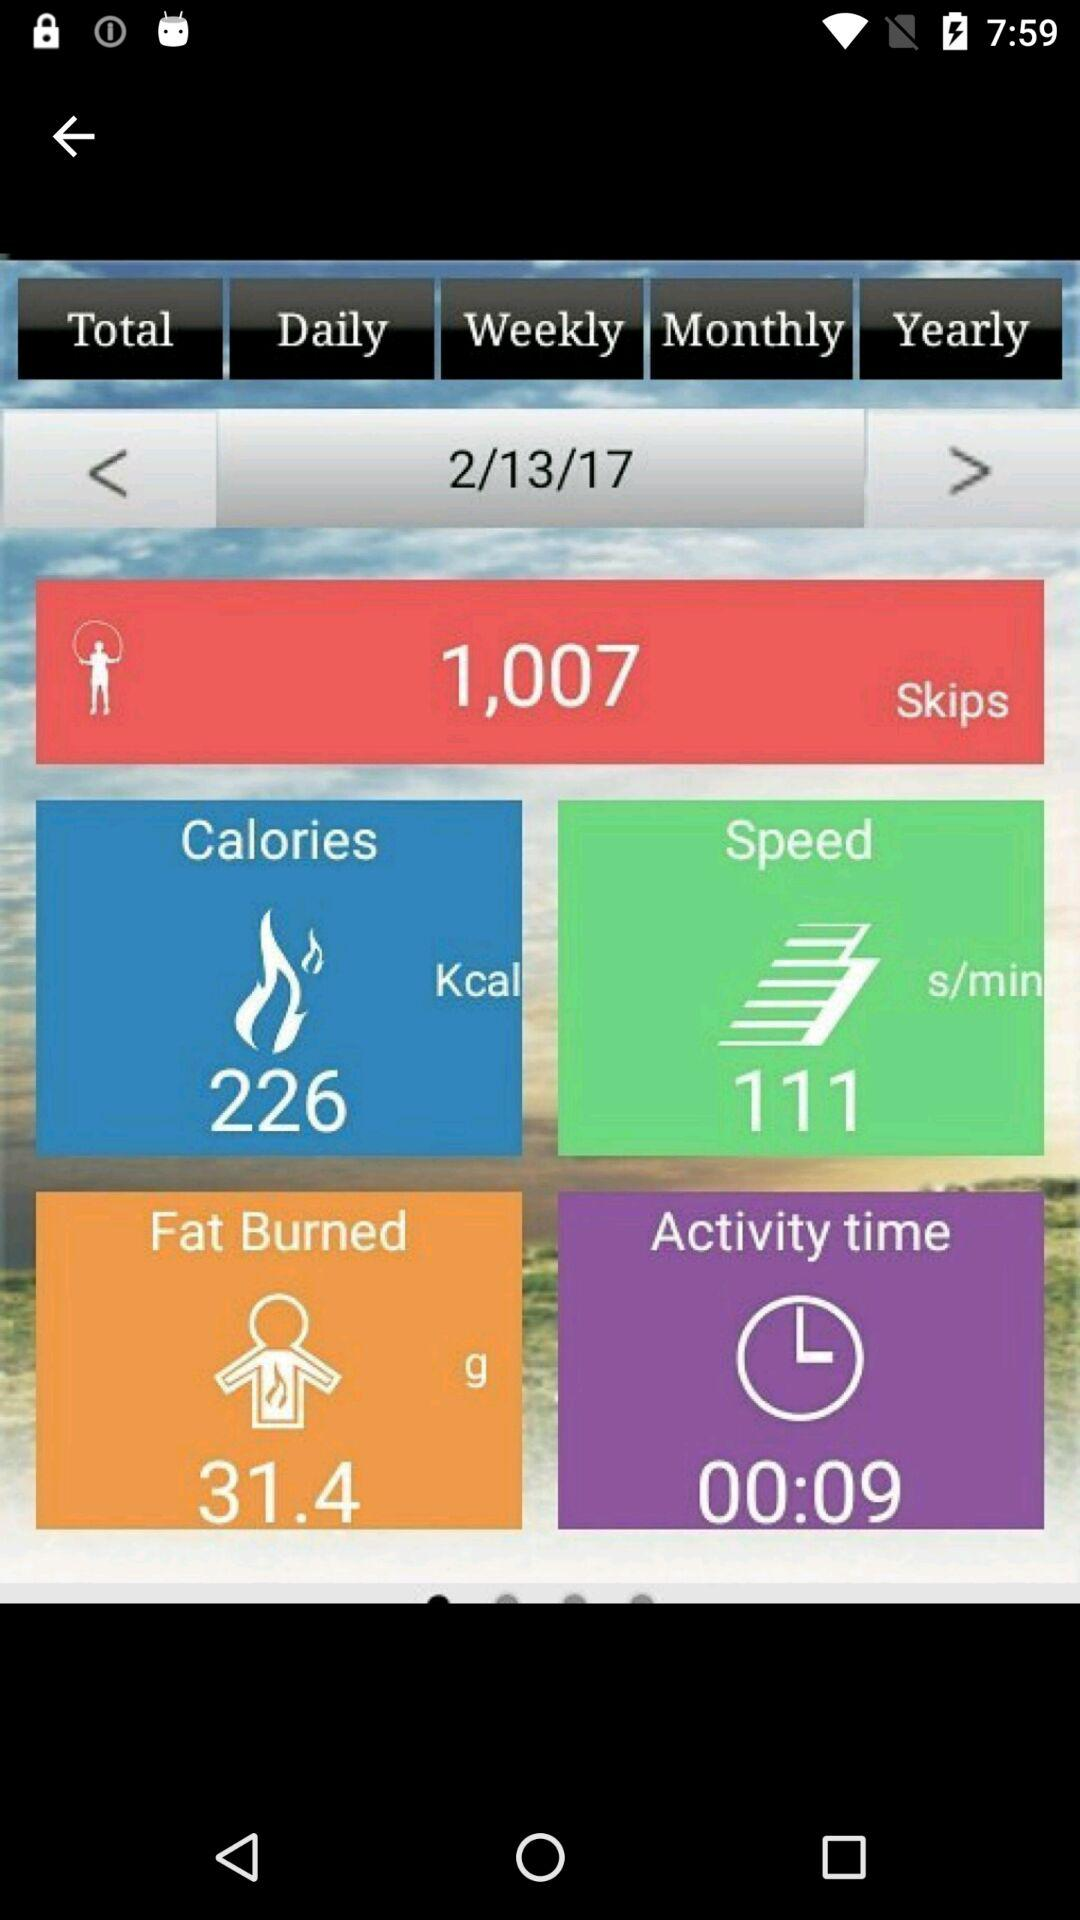How many calories were burned during this exercise?
Answer the question using a single word or phrase. 226 